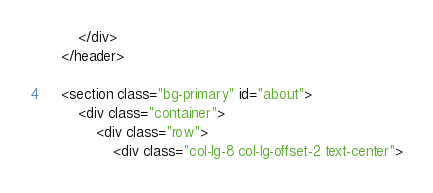Convert code to text. <code><loc_0><loc_0><loc_500><loc_500><_HTML_>        </div>
    </header>

    <section class="bg-primary" id="about">
        <div class="container">
            <div class="row">
                <div class="col-lg-8 col-lg-offset-2 text-center"></code> 